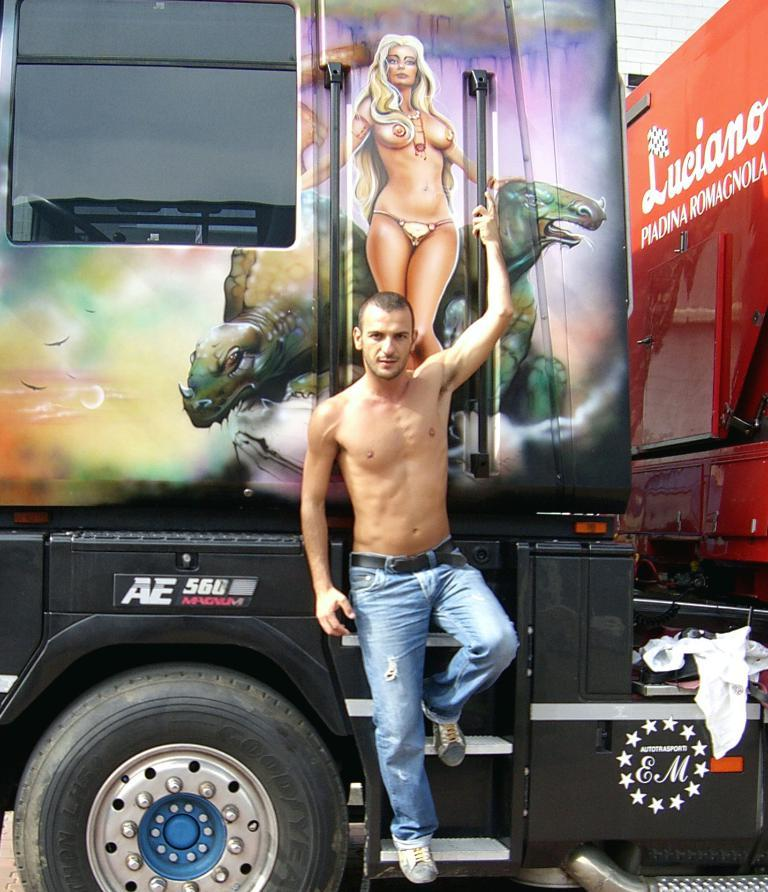What is the man in the image doing? The man is standing on a vehicle in the image. What is on the vehicle with the man? There is a board on the vehicle. What is depicted on the board? The board contains a picture of a woman and animals. Is there any text visible on the vehicle? Yes, there is text on the vehicle. What type of rod is the man using to balance on the vehicle? There is no rod visible in the image; the man is simply standing on the vehicle. 